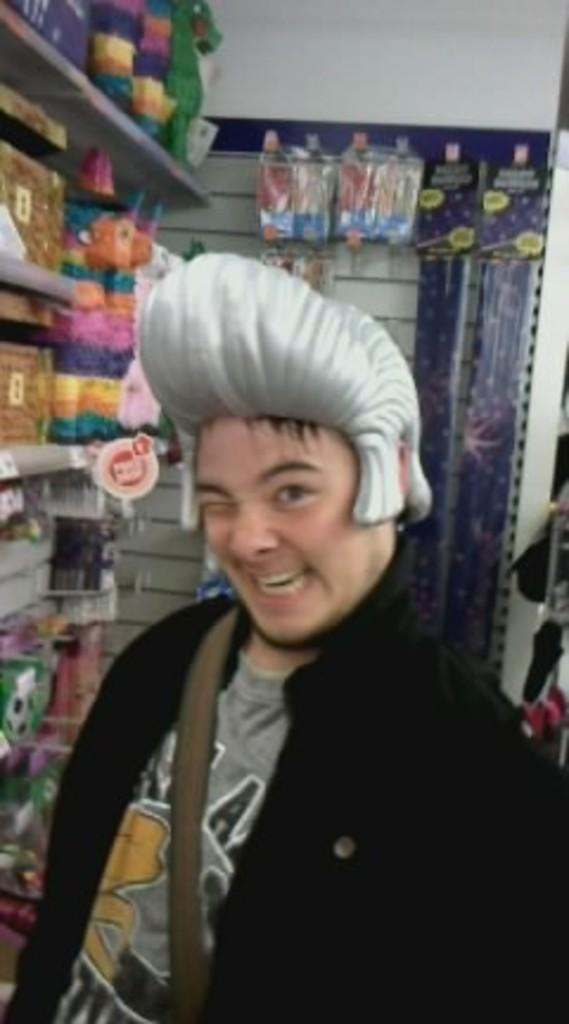Who is present in the image? There is a man in the image. What is the man wearing? The man is wearing a grey t-shirt and a black coat. What can be seen in the background of the image? There is a rack in the image. What is on the rack? There are various items arranged in the rack. What type of observation is the man making in the image? There is no indication in the image of the man making any specific observation, so it cannot be determined from the image. 